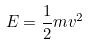<formula> <loc_0><loc_0><loc_500><loc_500>E = \frac { 1 } { 2 } m v ^ { 2 }</formula> 